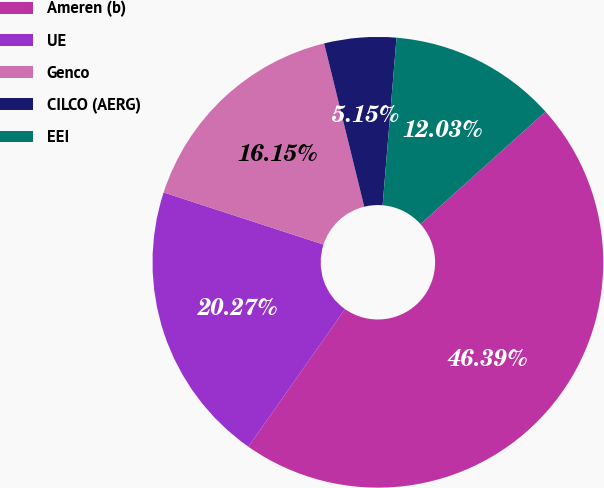Convert chart to OTSL. <chart><loc_0><loc_0><loc_500><loc_500><pie_chart><fcel>Ameren (b)<fcel>UE<fcel>Genco<fcel>CILCO (AERG)<fcel>EEI<nl><fcel>46.39%<fcel>20.27%<fcel>16.15%<fcel>5.15%<fcel>12.03%<nl></chart> 